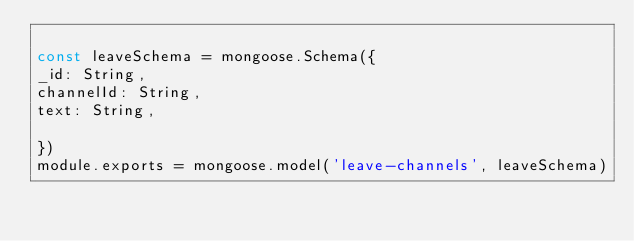Convert code to text. <code><loc_0><loc_0><loc_500><loc_500><_JavaScript_>
const leaveSchema = mongoose.Schema({
_id: String,
channelId: String,
text: String,
    
})
module.exports = mongoose.model('leave-channels', leaveSchema)</code> 